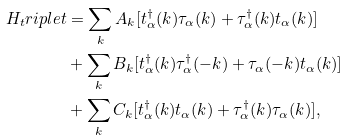<formula> <loc_0><loc_0><loc_500><loc_500>H _ { t } r i p l e t & = \sum _ { k } A _ { k } [ t ^ { \dag } _ { \alpha } ( k ) \tau _ { \alpha } ( k ) + \tau ^ { \dag } _ { \alpha } ( k ) t _ { \alpha } ( k ) ] \\ & + \sum _ { k } B _ { k } [ t ^ { \dag } _ { \alpha } ( k ) \tau ^ { \dag } _ { \alpha } ( - k ) + \tau _ { \alpha } ( - k ) t _ { \alpha } ( k ) ] \\ & + \sum _ { k } C _ { k } [ t ^ { \dag } _ { \alpha } ( k ) t _ { \alpha } ( k ) + \tau ^ { \dag } _ { \alpha } ( k ) \tau _ { \alpha } ( k ) ] ,</formula> 